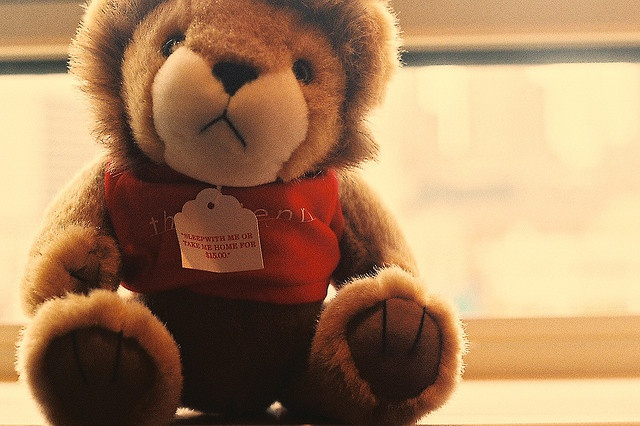Describe the objects in this image and their specific colors. I can see a teddy bear in gray, black, maroon, brown, and tan tones in this image. 